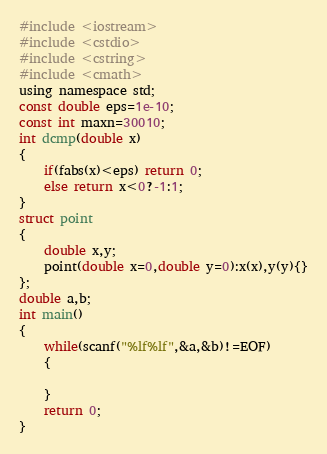<code> <loc_0><loc_0><loc_500><loc_500><_C_>#include <iostream>
#include <cstdio>
#include <cstring>
#include <cmath>
using namespace std;
const double eps=1e-10;
const int maxn=30010;
int dcmp(double x)
{
    if(fabs(x)<eps) return 0;
    else return x<0?-1:1;
}
struct point
{
    double x,y;
    point(double x=0,double y=0):x(x),y(y){}
};
double a,b;
int main()
{
    while(scanf("%lf%lf",&a,&b)!=EOF)
    {

    }
    return 0;
}</code> 